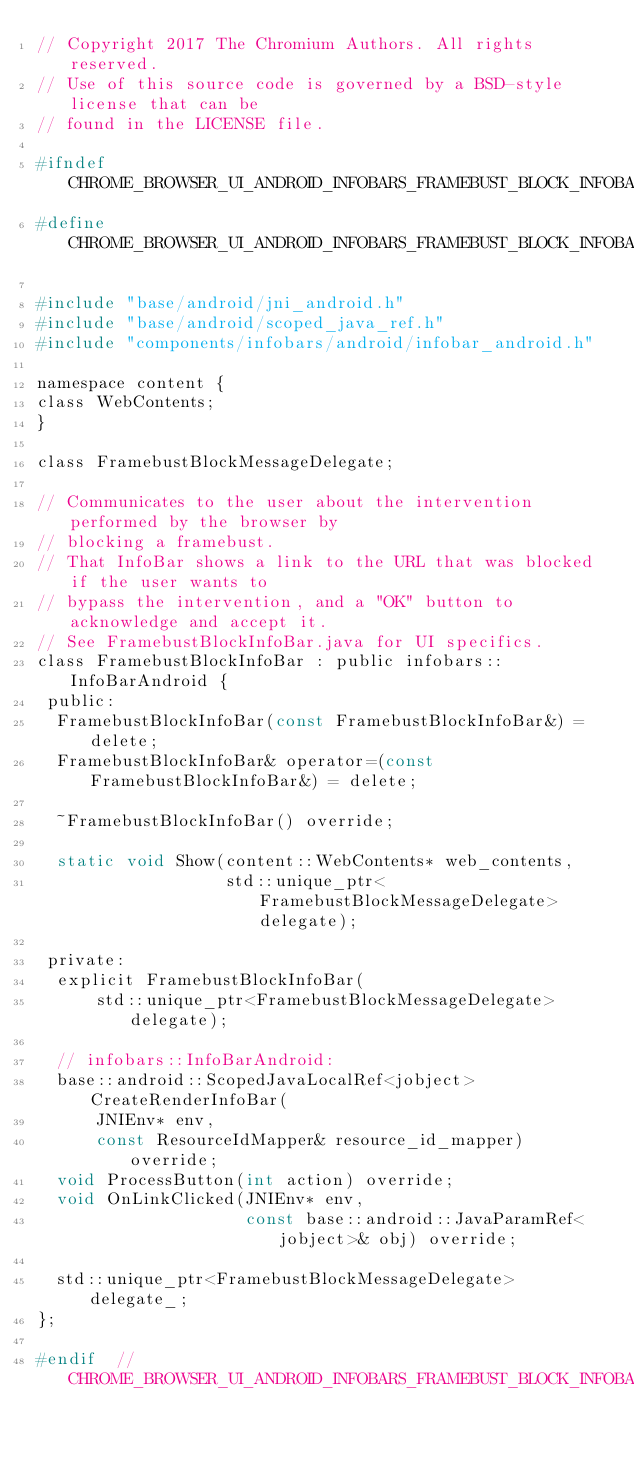Convert code to text. <code><loc_0><loc_0><loc_500><loc_500><_C_>// Copyright 2017 The Chromium Authors. All rights reserved.
// Use of this source code is governed by a BSD-style license that can be
// found in the LICENSE file.

#ifndef CHROME_BROWSER_UI_ANDROID_INFOBARS_FRAMEBUST_BLOCK_INFOBAR_H_
#define CHROME_BROWSER_UI_ANDROID_INFOBARS_FRAMEBUST_BLOCK_INFOBAR_H_

#include "base/android/jni_android.h"
#include "base/android/scoped_java_ref.h"
#include "components/infobars/android/infobar_android.h"

namespace content {
class WebContents;
}

class FramebustBlockMessageDelegate;

// Communicates to the user about the intervention performed by the browser by
// blocking a framebust.
// That InfoBar shows a link to the URL that was blocked if the user wants to
// bypass the intervention, and a "OK" button to acknowledge and accept it.
// See FramebustBlockInfoBar.java for UI specifics.
class FramebustBlockInfoBar : public infobars::InfoBarAndroid {
 public:
  FramebustBlockInfoBar(const FramebustBlockInfoBar&) = delete;
  FramebustBlockInfoBar& operator=(const FramebustBlockInfoBar&) = delete;

  ~FramebustBlockInfoBar() override;

  static void Show(content::WebContents* web_contents,
                   std::unique_ptr<FramebustBlockMessageDelegate> delegate);

 private:
  explicit FramebustBlockInfoBar(
      std::unique_ptr<FramebustBlockMessageDelegate> delegate);

  // infobars::InfoBarAndroid:
  base::android::ScopedJavaLocalRef<jobject> CreateRenderInfoBar(
      JNIEnv* env,
      const ResourceIdMapper& resource_id_mapper) override;
  void ProcessButton(int action) override;
  void OnLinkClicked(JNIEnv* env,
                     const base::android::JavaParamRef<jobject>& obj) override;

  std::unique_ptr<FramebustBlockMessageDelegate> delegate_;
};

#endif  // CHROME_BROWSER_UI_ANDROID_INFOBARS_FRAMEBUST_BLOCK_INFOBAR_H_
</code> 